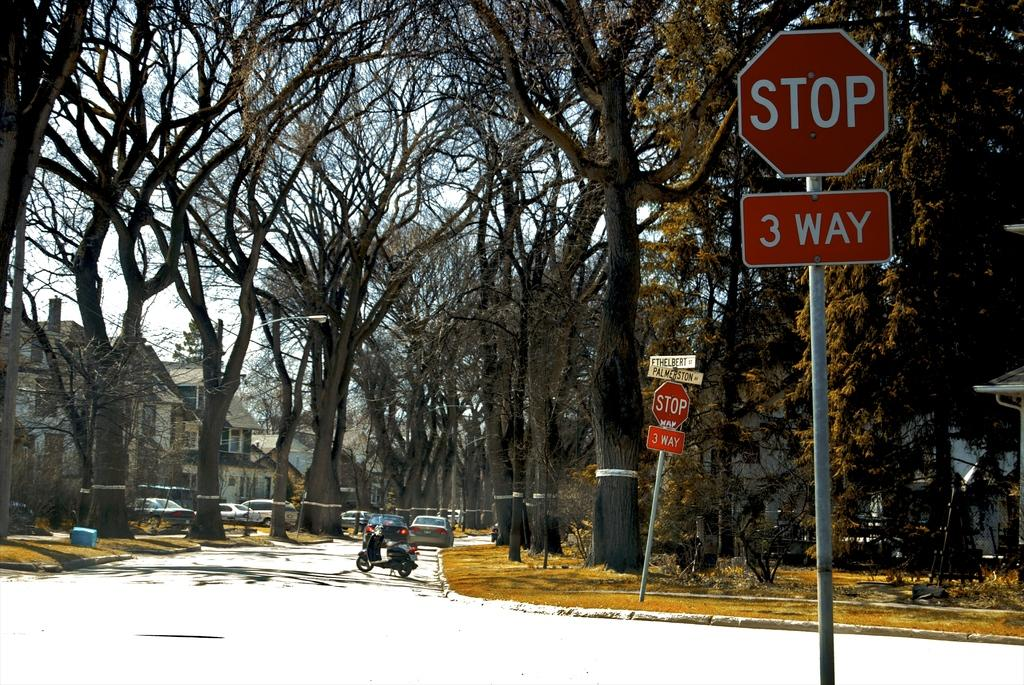Provide a one-sentence caption for the provided image. Vehicles on a residential street with a three way stop. 